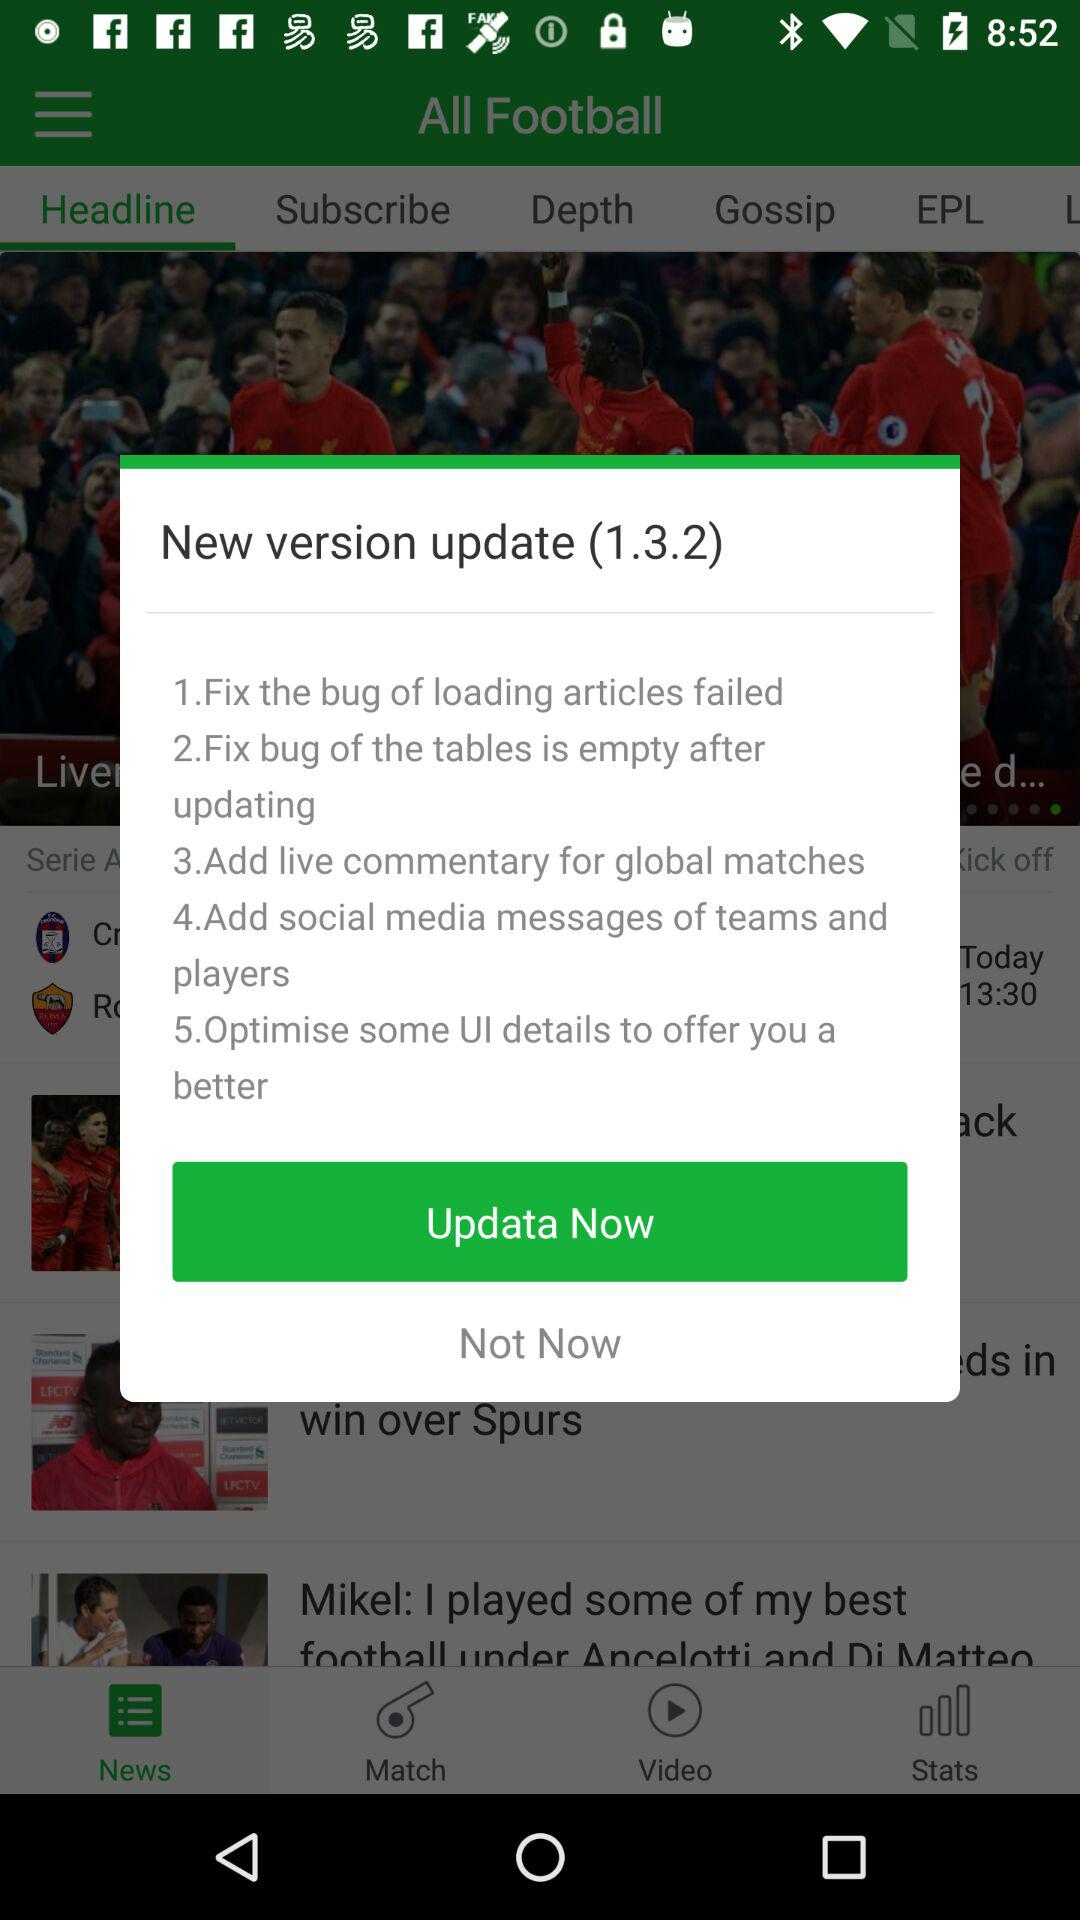Which tab is selected? The selected tab is "Headline". 